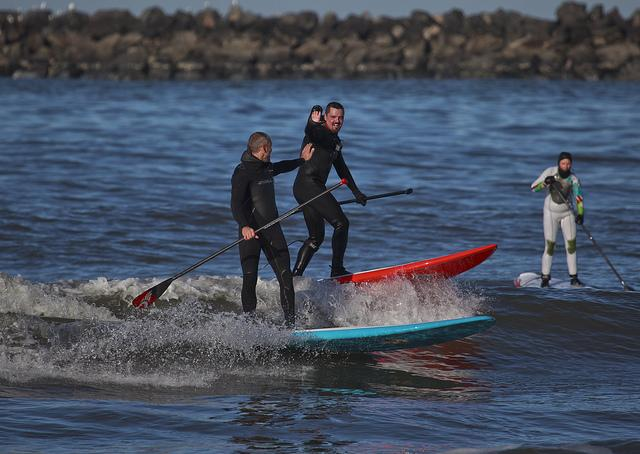Which artist depicted Polynesians practicing this sport on the Sandwich Islands?

Choices:
A) paul gauguin
B) georges seurat
C) michael donahue
D) john webber john webber 